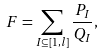<formula> <loc_0><loc_0><loc_500><loc_500>F = \sum _ { I \subseteq [ 1 , l ] } \frac { P _ { I } } { Q _ { I } } ,</formula> 